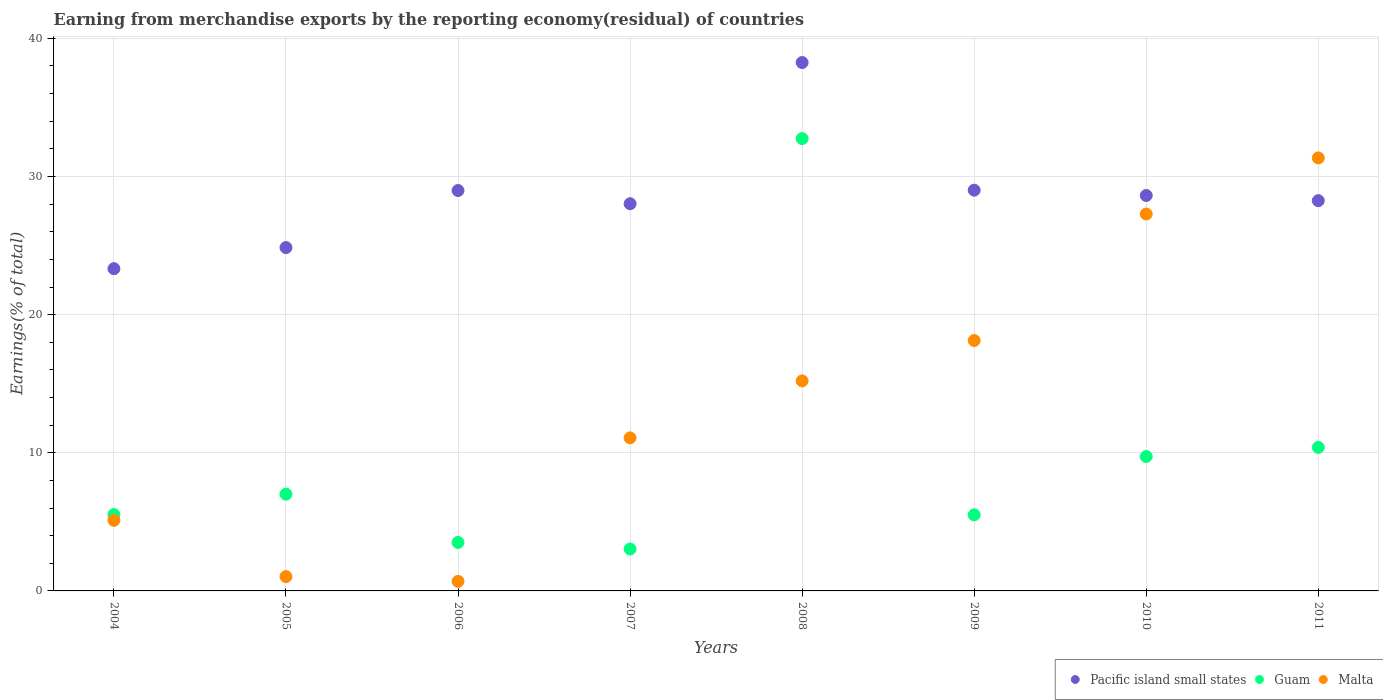How many different coloured dotlines are there?
Offer a terse response. 3. What is the percentage of amount earned from merchandise exports in Pacific island small states in 2006?
Keep it short and to the point. 28.99. Across all years, what is the maximum percentage of amount earned from merchandise exports in Guam?
Your response must be concise. 32.74. Across all years, what is the minimum percentage of amount earned from merchandise exports in Pacific island small states?
Ensure brevity in your answer.  23.33. What is the total percentage of amount earned from merchandise exports in Malta in the graph?
Keep it short and to the point. 109.88. What is the difference between the percentage of amount earned from merchandise exports in Guam in 2006 and that in 2011?
Ensure brevity in your answer.  -6.88. What is the difference between the percentage of amount earned from merchandise exports in Pacific island small states in 2006 and the percentage of amount earned from merchandise exports in Malta in 2004?
Your answer should be compact. 23.88. What is the average percentage of amount earned from merchandise exports in Malta per year?
Give a very brief answer. 13.74. In the year 2006, what is the difference between the percentage of amount earned from merchandise exports in Malta and percentage of amount earned from merchandise exports in Guam?
Keep it short and to the point. -2.82. What is the ratio of the percentage of amount earned from merchandise exports in Guam in 2005 to that in 2009?
Keep it short and to the point. 1.27. Is the difference between the percentage of amount earned from merchandise exports in Malta in 2010 and 2011 greater than the difference between the percentage of amount earned from merchandise exports in Guam in 2010 and 2011?
Keep it short and to the point. No. What is the difference between the highest and the second highest percentage of amount earned from merchandise exports in Guam?
Your answer should be very brief. 22.36. What is the difference between the highest and the lowest percentage of amount earned from merchandise exports in Guam?
Your answer should be very brief. 29.71. Is it the case that in every year, the sum of the percentage of amount earned from merchandise exports in Malta and percentage of amount earned from merchandise exports in Guam  is greater than the percentage of amount earned from merchandise exports in Pacific island small states?
Your answer should be very brief. No. Does the percentage of amount earned from merchandise exports in Guam monotonically increase over the years?
Keep it short and to the point. No. Is the percentage of amount earned from merchandise exports in Malta strictly less than the percentage of amount earned from merchandise exports in Pacific island small states over the years?
Offer a very short reply. No. How many dotlines are there?
Provide a short and direct response. 3. Does the graph contain grids?
Provide a succinct answer. Yes. Where does the legend appear in the graph?
Provide a succinct answer. Bottom right. How are the legend labels stacked?
Offer a terse response. Horizontal. What is the title of the graph?
Offer a very short reply. Earning from merchandise exports by the reporting economy(residual) of countries. Does "St. Lucia" appear as one of the legend labels in the graph?
Offer a terse response. No. What is the label or title of the X-axis?
Provide a succinct answer. Years. What is the label or title of the Y-axis?
Provide a succinct answer. Earnings(% of total). What is the Earnings(% of total) in Pacific island small states in 2004?
Offer a very short reply. 23.33. What is the Earnings(% of total) of Guam in 2004?
Your answer should be compact. 5.53. What is the Earnings(% of total) in Malta in 2004?
Ensure brevity in your answer.  5.11. What is the Earnings(% of total) of Pacific island small states in 2005?
Your answer should be very brief. 24.86. What is the Earnings(% of total) of Guam in 2005?
Keep it short and to the point. 7. What is the Earnings(% of total) of Malta in 2005?
Give a very brief answer. 1.04. What is the Earnings(% of total) in Pacific island small states in 2006?
Ensure brevity in your answer.  28.99. What is the Earnings(% of total) in Guam in 2006?
Your answer should be very brief. 3.51. What is the Earnings(% of total) of Malta in 2006?
Provide a short and direct response. 0.69. What is the Earnings(% of total) in Pacific island small states in 2007?
Offer a terse response. 28.03. What is the Earnings(% of total) in Guam in 2007?
Ensure brevity in your answer.  3.04. What is the Earnings(% of total) in Malta in 2007?
Provide a short and direct response. 11.08. What is the Earnings(% of total) in Pacific island small states in 2008?
Provide a succinct answer. 38.25. What is the Earnings(% of total) in Guam in 2008?
Provide a succinct answer. 32.74. What is the Earnings(% of total) of Malta in 2008?
Provide a short and direct response. 15.2. What is the Earnings(% of total) of Pacific island small states in 2009?
Offer a terse response. 29.01. What is the Earnings(% of total) in Guam in 2009?
Give a very brief answer. 5.51. What is the Earnings(% of total) in Malta in 2009?
Your response must be concise. 18.13. What is the Earnings(% of total) in Pacific island small states in 2010?
Offer a terse response. 28.63. What is the Earnings(% of total) of Guam in 2010?
Ensure brevity in your answer.  9.73. What is the Earnings(% of total) of Malta in 2010?
Ensure brevity in your answer.  27.29. What is the Earnings(% of total) in Pacific island small states in 2011?
Ensure brevity in your answer.  28.25. What is the Earnings(% of total) of Guam in 2011?
Give a very brief answer. 10.39. What is the Earnings(% of total) in Malta in 2011?
Provide a succinct answer. 31.34. Across all years, what is the maximum Earnings(% of total) of Pacific island small states?
Ensure brevity in your answer.  38.25. Across all years, what is the maximum Earnings(% of total) of Guam?
Offer a very short reply. 32.74. Across all years, what is the maximum Earnings(% of total) in Malta?
Keep it short and to the point. 31.34. Across all years, what is the minimum Earnings(% of total) of Pacific island small states?
Your answer should be very brief. 23.33. Across all years, what is the minimum Earnings(% of total) in Guam?
Offer a terse response. 3.04. Across all years, what is the minimum Earnings(% of total) in Malta?
Give a very brief answer. 0.69. What is the total Earnings(% of total) in Pacific island small states in the graph?
Ensure brevity in your answer.  229.34. What is the total Earnings(% of total) of Guam in the graph?
Give a very brief answer. 77.45. What is the total Earnings(% of total) of Malta in the graph?
Keep it short and to the point. 109.88. What is the difference between the Earnings(% of total) of Pacific island small states in 2004 and that in 2005?
Give a very brief answer. -1.53. What is the difference between the Earnings(% of total) of Guam in 2004 and that in 2005?
Keep it short and to the point. -1.48. What is the difference between the Earnings(% of total) of Malta in 2004 and that in 2005?
Keep it short and to the point. 4.07. What is the difference between the Earnings(% of total) of Pacific island small states in 2004 and that in 2006?
Offer a terse response. -5.66. What is the difference between the Earnings(% of total) in Guam in 2004 and that in 2006?
Provide a succinct answer. 2.02. What is the difference between the Earnings(% of total) of Malta in 2004 and that in 2006?
Offer a terse response. 4.42. What is the difference between the Earnings(% of total) in Pacific island small states in 2004 and that in 2007?
Your answer should be compact. -4.7. What is the difference between the Earnings(% of total) of Guam in 2004 and that in 2007?
Provide a succinct answer. 2.49. What is the difference between the Earnings(% of total) in Malta in 2004 and that in 2007?
Provide a succinct answer. -5.97. What is the difference between the Earnings(% of total) of Pacific island small states in 2004 and that in 2008?
Offer a terse response. -14.92. What is the difference between the Earnings(% of total) of Guam in 2004 and that in 2008?
Your answer should be compact. -27.22. What is the difference between the Earnings(% of total) of Malta in 2004 and that in 2008?
Make the answer very short. -10.09. What is the difference between the Earnings(% of total) in Pacific island small states in 2004 and that in 2009?
Make the answer very short. -5.68. What is the difference between the Earnings(% of total) of Guam in 2004 and that in 2009?
Ensure brevity in your answer.  0.02. What is the difference between the Earnings(% of total) in Malta in 2004 and that in 2009?
Provide a succinct answer. -13.02. What is the difference between the Earnings(% of total) of Pacific island small states in 2004 and that in 2010?
Provide a succinct answer. -5.3. What is the difference between the Earnings(% of total) of Guam in 2004 and that in 2010?
Your answer should be very brief. -4.2. What is the difference between the Earnings(% of total) in Malta in 2004 and that in 2010?
Your response must be concise. -22.18. What is the difference between the Earnings(% of total) in Pacific island small states in 2004 and that in 2011?
Ensure brevity in your answer.  -4.92. What is the difference between the Earnings(% of total) of Guam in 2004 and that in 2011?
Your response must be concise. -4.86. What is the difference between the Earnings(% of total) in Malta in 2004 and that in 2011?
Offer a terse response. -26.23. What is the difference between the Earnings(% of total) of Pacific island small states in 2005 and that in 2006?
Your response must be concise. -4.13. What is the difference between the Earnings(% of total) in Guam in 2005 and that in 2006?
Your answer should be compact. 3.49. What is the difference between the Earnings(% of total) in Malta in 2005 and that in 2006?
Your response must be concise. 0.35. What is the difference between the Earnings(% of total) in Pacific island small states in 2005 and that in 2007?
Your answer should be compact. -3.17. What is the difference between the Earnings(% of total) in Guam in 2005 and that in 2007?
Your answer should be compact. 3.97. What is the difference between the Earnings(% of total) of Malta in 2005 and that in 2007?
Your answer should be compact. -10.04. What is the difference between the Earnings(% of total) in Pacific island small states in 2005 and that in 2008?
Offer a very short reply. -13.4. What is the difference between the Earnings(% of total) in Guam in 2005 and that in 2008?
Make the answer very short. -25.74. What is the difference between the Earnings(% of total) in Malta in 2005 and that in 2008?
Your response must be concise. -14.17. What is the difference between the Earnings(% of total) of Pacific island small states in 2005 and that in 2009?
Your answer should be very brief. -4.15. What is the difference between the Earnings(% of total) in Guam in 2005 and that in 2009?
Provide a succinct answer. 1.5. What is the difference between the Earnings(% of total) of Malta in 2005 and that in 2009?
Keep it short and to the point. -17.09. What is the difference between the Earnings(% of total) of Pacific island small states in 2005 and that in 2010?
Offer a very short reply. -3.77. What is the difference between the Earnings(% of total) in Guam in 2005 and that in 2010?
Ensure brevity in your answer.  -2.73. What is the difference between the Earnings(% of total) of Malta in 2005 and that in 2010?
Provide a succinct answer. -26.25. What is the difference between the Earnings(% of total) in Pacific island small states in 2005 and that in 2011?
Provide a short and direct response. -3.4. What is the difference between the Earnings(% of total) of Guam in 2005 and that in 2011?
Ensure brevity in your answer.  -3.39. What is the difference between the Earnings(% of total) of Malta in 2005 and that in 2011?
Offer a terse response. -30.31. What is the difference between the Earnings(% of total) in Pacific island small states in 2006 and that in 2007?
Provide a short and direct response. 0.96. What is the difference between the Earnings(% of total) of Guam in 2006 and that in 2007?
Provide a succinct answer. 0.47. What is the difference between the Earnings(% of total) of Malta in 2006 and that in 2007?
Provide a succinct answer. -10.39. What is the difference between the Earnings(% of total) in Pacific island small states in 2006 and that in 2008?
Your response must be concise. -9.27. What is the difference between the Earnings(% of total) of Guam in 2006 and that in 2008?
Make the answer very short. -29.23. What is the difference between the Earnings(% of total) of Malta in 2006 and that in 2008?
Ensure brevity in your answer.  -14.51. What is the difference between the Earnings(% of total) in Pacific island small states in 2006 and that in 2009?
Your answer should be very brief. -0.02. What is the difference between the Earnings(% of total) of Guam in 2006 and that in 2009?
Offer a terse response. -2. What is the difference between the Earnings(% of total) of Malta in 2006 and that in 2009?
Keep it short and to the point. -17.44. What is the difference between the Earnings(% of total) in Pacific island small states in 2006 and that in 2010?
Provide a succinct answer. 0.36. What is the difference between the Earnings(% of total) of Guam in 2006 and that in 2010?
Make the answer very short. -6.22. What is the difference between the Earnings(% of total) in Malta in 2006 and that in 2010?
Your response must be concise. -26.59. What is the difference between the Earnings(% of total) in Pacific island small states in 2006 and that in 2011?
Ensure brevity in your answer.  0.73. What is the difference between the Earnings(% of total) in Guam in 2006 and that in 2011?
Provide a short and direct response. -6.88. What is the difference between the Earnings(% of total) in Malta in 2006 and that in 2011?
Give a very brief answer. -30.65. What is the difference between the Earnings(% of total) of Pacific island small states in 2007 and that in 2008?
Provide a short and direct response. -10.22. What is the difference between the Earnings(% of total) in Guam in 2007 and that in 2008?
Keep it short and to the point. -29.71. What is the difference between the Earnings(% of total) of Malta in 2007 and that in 2008?
Make the answer very short. -4.12. What is the difference between the Earnings(% of total) in Pacific island small states in 2007 and that in 2009?
Your response must be concise. -0.98. What is the difference between the Earnings(% of total) in Guam in 2007 and that in 2009?
Give a very brief answer. -2.47. What is the difference between the Earnings(% of total) in Malta in 2007 and that in 2009?
Ensure brevity in your answer.  -7.05. What is the difference between the Earnings(% of total) in Pacific island small states in 2007 and that in 2010?
Your response must be concise. -0.6. What is the difference between the Earnings(% of total) in Guam in 2007 and that in 2010?
Offer a very short reply. -6.69. What is the difference between the Earnings(% of total) of Malta in 2007 and that in 2010?
Your answer should be very brief. -16.2. What is the difference between the Earnings(% of total) in Pacific island small states in 2007 and that in 2011?
Make the answer very short. -0.22. What is the difference between the Earnings(% of total) of Guam in 2007 and that in 2011?
Provide a short and direct response. -7.35. What is the difference between the Earnings(% of total) of Malta in 2007 and that in 2011?
Your answer should be compact. -20.26. What is the difference between the Earnings(% of total) of Pacific island small states in 2008 and that in 2009?
Keep it short and to the point. 9.24. What is the difference between the Earnings(% of total) in Guam in 2008 and that in 2009?
Make the answer very short. 27.24. What is the difference between the Earnings(% of total) of Malta in 2008 and that in 2009?
Ensure brevity in your answer.  -2.92. What is the difference between the Earnings(% of total) in Pacific island small states in 2008 and that in 2010?
Keep it short and to the point. 9.63. What is the difference between the Earnings(% of total) of Guam in 2008 and that in 2010?
Ensure brevity in your answer.  23.02. What is the difference between the Earnings(% of total) of Malta in 2008 and that in 2010?
Offer a very short reply. -12.08. What is the difference between the Earnings(% of total) of Pacific island small states in 2008 and that in 2011?
Give a very brief answer. 10. What is the difference between the Earnings(% of total) in Guam in 2008 and that in 2011?
Give a very brief answer. 22.36. What is the difference between the Earnings(% of total) in Malta in 2008 and that in 2011?
Make the answer very short. -16.14. What is the difference between the Earnings(% of total) in Pacific island small states in 2009 and that in 2010?
Keep it short and to the point. 0.38. What is the difference between the Earnings(% of total) of Guam in 2009 and that in 2010?
Make the answer very short. -4.22. What is the difference between the Earnings(% of total) of Malta in 2009 and that in 2010?
Your answer should be very brief. -9.16. What is the difference between the Earnings(% of total) in Pacific island small states in 2009 and that in 2011?
Ensure brevity in your answer.  0.76. What is the difference between the Earnings(% of total) in Guam in 2009 and that in 2011?
Give a very brief answer. -4.88. What is the difference between the Earnings(% of total) in Malta in 2009 and that in 2011?
Ensure brevity in your answer.  -13.22. What is the difference between the Earnings(% of total) of Pacific island small states in 2010 and that in 2011?
Your response must be concise. 0.37. What is the difference between the Earnings(% of total) of Guam in 2010 and that in 2011?
Make the answer very short. -0.66. What is the difference between the Earnings(% of total) of Malta in 2010 and that in 2011?
Provide a short and direct response. -4.06. What is the difference between the Earnings(% of total) of Pacific island small states in 2004 and the Earnings(% of total) of Guam in 2005?
Make the answer very short. 16.32. What is the difference between the Earnings(% of total) in Pacific island small states in 2004 and the Earnings(% of total) in Malta in 2005?
Your answer should be very brief. 22.29. What is the difference between the Earnings(% of total) of Guam in 2004 and the Earnings(% of total) of Malta in 2005?
Keep it short and to the point. 4.49. What is the difference between the Earnings(% of total) of Pacific island small states in 2004 and the Earnings(% of total) of Guam in 2006?
Your response must be concise. 19.82. What is the difference between the Earnings(% of total) in Pacific island small states in 2004 and the Earnings(% of total) in Malta in 2006?
Your answer should be very brief. 22.64. What is the difference between the Earnings(% of total) of Guam in 2004 and the Earnings(% of total) of Malta in 2006?
Offer a terse response. 4.84. What is the difference between the Earnings(% of total) in Pacific island small states in 2004 and the Earnings(% of total) in Guam in 2007?
Offer a terse response. 20.29. What is the difference between the Earnings(% of total) in Pacific island small states in 2004 and the Earnings(% of total) in Malta in 2007?
Your answer should be very brief. 12.25. What is the difference between the Earnings(% of total) in Guam in 2004 and the Earnings(% of total) in Malta in 2007?
Your response must be concise. -5.55. What is the difference between the Earnings(% of total) of Pacific island small states in 2004 and the Earnings(% of total) of Guam in 2008?
Your response must be concise. -9.42. What is the difference between the Earnings(% of total) in Pacific island small states in 2004 and the Earnings(% of total) in Malta in 2008?
Your answer should be very brief. 8.12. What is the difference between the Earnings(% of total) of Guam in 2004 and the Earnings(% of total) of Malta in 2008?
Your answer should be very brief. -9.68. What is the difference between the Earnings(% of total) of Pacific island small states in 2004 and the Earnings(% of total) of Guam in 2009?
Give a very brief answer. 17.82. What is the difference between the Earnings(% of total) in Pacific island small states in 2004 and the Earnings(% of total) in Malta in 2009?
Your response must be concise. 5.2. What is the difference between the Earnings(% of total) in Guam in 2004 and the Earnings(% of total) in Malta in 2009?
Provide a succinct answer. -12.6. What is the difference between the Earnings(% of total) in Pacific island small states in 2004 and the Earnings(% of total) in Guam in 2010?
Offer a very short reply. 13.6. What is the difference between the Earnings(% of total) in Pacific island small states in 2004 and the Earnings(% of total) in Malta in 2010?
Provide a succinct answer. -3.96. What is the difference between the Earnings(% of total) in Guam in 2004 and the Earnings(% of total) in Malta in 2010?
Make the answer very short. -21.76. What is the difference between the Earnings(% of total) in Pacific island small states in 2004 and the Earnings(% of total) in Guam in 2011?
Offer a very short reply. 12.94. What is the difference between the Earnings(% of total) in Pacific island small states in 2004 and the Earnings(% of total) in Malta in 2011?
Provide a short and direct response. -8.02. What is the difference between the Earnings(% of total) in Guam in 2004 and the Earnings(% of total) in Malta in 2011?
Your response must be concise. -25.82. What is the difference between the Earnings(% of total) of Pacific island small states in 2005 and the Earnings(% of total) of Guam in 2006?
Ensure brevity in your answer.  21.35. What is the difference between the Earnings(% of total) in Pacific island small states in 2005 and the Earnings(% of total) in Malta in 2006?
Your answer should be compact. 24.16. What is the difference between the Earnings(% of total) in Guam in 2005 and the Earnings(% of total) in Malta in 2006?
Your answer should be very brief. 6.31. What is the difference between the Earnings(% of total) in Pacific island small states in 2005 and the Earnings(% of total) in Guam in 2007?
Give a very brief answer. 21.82. What is the difference between the Earnings(% of total) of Pacific island small states in 2005 and the Earnings(% of total) of Malta in 2007?
Offer a very short reply. 13.78. What is the difference between the Earnings(% of total) of Guam in 2005 and the Earnings(% of total) of Malta in 2007?
Your answer should be very brief. -4.08. What is the difference between the Earnings(% of total) of Pacific island small states in 2005 and the Earnings(% of total) of Guam in 2008?
Give a very brief answer. -7.89. What is the difference between the Earnings(% of total) of Pacific island small states in 2005 and the Earnings(% of total) of Malta in 2008?
Make the answer very short. 9.65. What is the difference between the Earnings(% of total) of Guam in 2005 and the Earnings(% of total) of Malta in 2008?
Give a very brief answer. -8.2. What is the difference between the Earnings(% of total) in Pacific island small states in 2005 and the Earnings(% of total) in Guam in 2009?
Ensure brevity in your answer.  19.35. What is the difference between the Earnings(% of total) in Pacific island small states in 2005 and the Earnings(% of total) in Malta in 2009?
Give a very brief answer. 6.73. What is the difference between the Earnings(% of total) in Guam in 2005 and the Earnings(% of total) in Malta in 2009?
Your answer should be compact. -11.12. What is the difference between the Earnings(% of total) in Pacific island small states in 2005 and the Earnings(% of total) in Guam in 2010?
Keep it short and to the point. 15.13. What is the difference between the Earnings(% of total) of Pacific island small states in 2005 and the Earnings(% of total) of Malta in 2010?
Offer a terse response. -2.43. What is the difference between the Earnings(% of total) of Guam in 2005 and the Earnings(% of total) of Malta in 2010?
Make the answer very short. -20.28. What is the difference between the Earnings(% of total) in Pacific island small states in 2005 and the Earnings(% of total) in Guam in 2011?
Ensure brevity in your answer.  14.47. What is the difference between the Earnings(% of total) of Pacific island small states in 2005 and the Earnings(% of total) of Malta in 2011?
Keep it short and to the point. -6.49. What is the difference between the Earnings(% of total) in Guam in 2005 and the Earnings(% of total) in Malta in 2011?
Offer a terse response. -24.34. What is the difference between the Earnings(% of total) in Pacific island small states in 2006 and the Earnings(% of total) in Guam in 2007?
Your response must be concise. 25.95. What is the difference between the Earnings(% of total) of Pacific island small states in 2006 and the Earnings(% of total) of Malta in 2007?
Give a very brief answer. 17.9. What is the difference between the Earnings(% of total) in Guam in 2006 and the Earnings(% of total) in Malta in 2007?
Provide a short and direct response. -7.57. What is the difference between the Earnings(% of total) of Pacific island small states in 2006 and the Earnings(% of total) of Guam in 2008?
Offer a terse response. -3.76. What is the difference between the Earnings(% of total) of Pacific island small states in 2006 and the Earnings(% of total) of Malta in 2008?
Make the answer very short. 13.78. What is the difference between the Earnings(% of total) in Guam in 2006 and the Earnings(% of total) in Malta in 2008?
Your answer should be very brief. -11.69. What is the difference between the Earnings(% of total) in Pacific island small states in 2006 and the Earnings(% of total) in Guam in 2009?
Ensure brevity in your answer.  23.48. What is the difference between the Earnings(% of total) of Pacific island small states in 2006 and the Earnings(% of total) of Malta in 2009?
Provide a succinct answer. 10.86. What is the difference between the Earnings(% of total) of Guam in 2006 and the Earnings(% of total) of Malta in 2009?
Your answer should be very brief. -14.62. What is the difference between the Earnings(% of total) of Pacific island small states in 2006 and the Earnings(% of total) of Guam in 2010?
Offer a very short reply. 19.26. What is the difference between the Earnings(% of total) of Pacific island small states in 2006 and the Earnings(% of total) of Malta in 2010?
Your answer should be compact. 1.7. What is the difference between the Earnings(% of total) in Guam in 2006 and the Earnings(% of total) in Malta in 2010?
Keep it short and to the point. -23.77. What is the difference between the Earnings(% of total) in Pacific island small states in 2006 and the Earnings(% of total) in Guam in 2011?
Your answer should be compact. 18.6. What is the difference between the Earnings(% of total) of Pacific island small states in 2006 and the Earnings(% of total) of Malta in 2011?
Give a very brief answer. -2.36. What is the difference between the Earnings(% of total) of Guam in 2006 and the Earnings(% of total) of Malta in 2011?
Give a very brief answer. -27.83. What is the difference between the Earnings(% of total) of Pacific island small states in 2007 and the Earnings(% of total) of Guam in 2008?
Your response must be concise. -4.72. What is the difference between the Earnings(% of total) in Pacific island small states in 2007 and the Earnings(% of total) in Malta in 2008?
Make the answer very short. 12.83. What is the difference between the Earnings(% of total) in Guam in 2007 and the Earnings(% of total) in Malta in 2008?
Your answer should be compact. -12.17. What is the difference between the Earnings(% of total) in Pacific island small states in 2007 and the Earnings(% of total) in Guam in 2009?
Give a very brief answer. 22.52. What is the difference between the Earnings(% of total) in Pacific island small states in 2007 and the Earnings(% of total) in Malta in 2009?
Offer a very short reply. 9.9. What is the difference between the Earnings(% of total) of Guam in 2007 and the Earnings(% of total) of Malta in 2009?
Keep it short and to the point. -15.09. What is the difference between the Earnings(% of total) of Pacific island small states in 2007 and the Earnings(% of total) of Guam in 2010?
Provide a succinct answer. 18.3. What is the difference between the Earnings(% of total) of Pacific island small states in 2007 and the Earnings(% of total) of Malta in 2010?
Offer a terse response. 0.74. What is the difference between the Earnings(% of total) of Guam in 2007 and the Earnings(% of total) of Malta in 2010?
Offer a terse response. -24.25. What is the difference between the Earnings(% of total) in Pacific island small states in 2007 and the Earnings(% of total) in Guam in 2011?
Provide a short and direct response. 17.64. What is the difference between the Earnings(% of total) in Pacific island small states in 2007 and the Earnings(% of total) in Malta in 2011?
Offer a very short reply. -3.31. What is the difference between the Earnings(% of total) of Guam in 2007 and the Earnings(% of total) of Malta in 2011?
Make the answer very short. -28.31. What is the difference between the Earnings(% of total) of Pacific island small states in 2008 and the Earnings(% of total) of Guam in 2009?
Ensure brevity in your answer.  32.74. What is the difference between the Earnings(% of total) in Pacific island small states in 2008 and the Earnings(% of total) in Malta in 2009?
Your answer should be very brief. 20.12. What is the difference between the Earnings(% of total) of Guam in 2008 and the Earnings(% of total) of Malta in 2009?
Your response must be concise. 14.62. What is the difference between the Earnings(% of total) of Pacific island small states in 2008 and the Earnings(% of total) of Guam in 2010?
Ensure brevity in your answer.  28.52. What is the difference between the Earnings(% of total) of Pacific island small states in 2008 and the Earnings(% of total) of Malta in 2010?
Provide a succinct answer. 10.97. What is the difference between the Earnings(% of total) in Guam in 2008 and the Earnings(% of total) in Malta in 2010?
Provide a short and direct response. 5.46. What is the difference between the Earnings(% of total) in Pacific island small states in 2008 and the Earnings(% of total) in Guam in 2011?
Your answer should be very brief. 27.86. What is the difference between the Earnings(% of total) in Pacific island small states in 2008 and the Earnings(% of total) in Malta in 2011?
Your response must be concise. 6.91. What is the difference between the Earnings(% of total) in Guam in 2008 and the Earnings(% of total) in Malta in 2011?
Make the answer very short. 1.4. What is the difference between the Earnings(% of total) of Pacific island small states in 2009 and the Earnings(% of total) of Guam in 2010?
Ensure brevity in your answer.  19.28. What is the difference between the Earnings(% of total) of Pacific island small states in 2009 and the Earnings(% of total) of Malta in 2010?
Ensure brevity in your answer.  1.72. What is the difference between the Earnings(% of total) in Guam in 2009 and the Earnings(% of total) in Malta in 2010?
Provide a succinct answer. -21.78. What is the difference between the Earnings(% of total) of Pacific island small states in 2009 and the Earnings(% of total) of Guam in 2011?
Your answer should be compact. 18.62. What is the difference between the Earnings(% of total) of Pacific island small states in 2009 and the Earnings(% of total) of Malta in 2011?
Your response must be concise. -2.33. What is the difference between the Earnings(% of total) of Guam in 2009 and the Earnings(% of total) of Malta in 2011?
Your response must be concise. -25.84. What is the difference between the Earnings(% of total) of Pacific island small states in 2010 and the Earnings(% of total) of Guam in 2011?
Offer a terse response. 18.24. What is the difference between the Earnings(% of total) of Pacific island small states in 2010 and the Earnings(% of total) of Malta in 2011?
Ensure brevity in your answer.  -2.72. What is the difference between the Earnings(% of total) of Guam in 2010 and the Earnings(% of total) of Malta in 2011?
Your answer should be very brief. -21.62. What is the average Earnings(% of total) in Pacific island small states per year?
Make the answer very short. 28.67. What is the average Earnings(% of total) of Guam per year?
Your answer should be very brief. 9.68. What is the average Earnings(% of total) in Malta per year?
Your answer should be very brief. 13.74. In the year 2004, what is the difference between the Earnings(% of total) of Pacific island small states and Earnings(% of total) of Guam?
Make the answer very short. 17.8. In the year 2004, what is the difference between the Earnings(% of total) of Pacific island small states and Earnings(% of total) of Malta?
Your answer should be very brief. 18.22. In the year 2004, what is the difference between the Earnings(% of total) in Guam and Earnings(% of total) in Malta?
Ensure brevity in your answer.  0.42. In the year 2005, what is the difference between the Earnings(% of total) in Pacific island small states and Earnings(% of total) in Guam?
Keep it short and to the point. 17.85. In the year 2005, what is the difference between the Earnings(% of total) in Pacific island small states and Earnings(% of total) in Malta?
Your response must be concise. 23.82. In the year 2005, what is the difference between the Earnings(% of total) of Guam and Earnings(% of total) of Malta?
Ensure brevity in your answer.  5.97. In the year 2006, what is the difference between the Earnings(% of total) of Pacific island small states and Earnings(% of total) of Guam?
Your answer should be very brief. 25.47. In the year 2006, what is the difference between the Earnings(% of total) in Pacific island small states and Earnings(% of total) in Malta?
Make the answer very short. 28.29. In the year 2006, what is the difference between the Earnings(% of total) of Guam and Earnings(% of total) of Malta?
Give a very brief answer. 2.82. In the year 2007, what is the difference between the Earnings(% of total) in Pacific island small states and Earnings(% of total) in Guam?
Offer a terse response. 24.99. In the year 2007, what is the difference between the Earnings(% of total) in Pacific island small states and Earnings(% of total) in Malta?
Your response must be concise. 16.95. In the year 2007, what is the difference between the Earnings(% of total) in Guam and Earnings(% of total) in Malta?
Make the answer very short. -8.04. In the year 2008, what is the difference between the Earnings(% of total) of Pacific island small states and Earnings(% of total) of Guam?
Your answer should be very brief. 5.51. In the year 2008, what is the difference between the Earnings(% of total) in Pacific island small states and Earnings(% of total) in Malta?
Your answer should be very brief. 23.05. In the year 2008, what is the difference between the Earnings(% of total) in Guam and Earnings(% of total) in Malta?
Provide a short and direct response. 17.54. In the year 2009, what is the difference between the Earnings(% of total) of Pacific island small states and Earnings(% of total) of Guam?
Make the answer very short. 23.5. In the year 2009, what is the difference between the Earnings(% of total) of Pacific island small states and Earnings(% of total) of Malta?
Your response must be concise. 10.88. In the year 2009, what is the difference between the Earnings(% of total) of Guam and Earnings(% of total) of Malta?
Give a very brief answer. -12.62. In the year 2010, what is the difference between the Earnings(% of total) in Pacific island small states and Earnings(% of total) in Guam?
Make the answer very short. 18.9. In the year 2010, what is the difference between the Earnings(% of total) in Pacific island small states and Earnings(% of total) in Malta?
Give a very brief answer. 1.34. In the year 2010, what is the difference between the Earnings(% of total) in Guam and Earnings(% of total) in Malta?
Your response must be concise. -17.56. In the year 2011, what is the difference between the Earnings(% of total) of Pacific island small states and Earnings(% of total) of Guam?
Make the answer very short. 17.86. In the year 2011, what is the difference between the Earnings(% of total) of Pacific island small states and Earnings(% of total) of Malta?
Offer a very short reply. -3.09. In the year 2011, what is the difference between the Earnings(% of total) in Guam and Earnings(% of total) in Malta?
Keep it short and to the point. -20.95. What is the ratio of the Earnings(% of total) in Pacific island small states in 2004 to that in 2005?
Give a very brief answer. 0.94. What is the ratio of the Earnings(% of total) in Guam in 2004 to that in 2005?
Keep it short and to the point. 0.79. What is the ratio of the Earnings(% of total) of Malta in 2004 to that in 2005?
Ensure brevity in your answer.  4.93. What is the ratio of the Earnings(% of total) of Pacific island small states in 2004 to that in 2006?
Ensure brevity in your answer.  0.8. What is the ratio of the Earnings(% of total) of Guam in 2004 to that in 2006?
Keep it short and to the point. 1.57. What is the ratio of the Earnings(% of total) in Malta in 2004 to that in 2006?
Your response must be concise. 7.38. What is the ratio of the Earnings(% of total) in Pacific island small states in 2004 to that in 2007?
Provide a short and direct response. 0.83. What is the ratio of the Earnings(% of total) in Guam in 2004 to that in 2007?
Keep it short and to the point. 1.82. What is the ratio of the Earnings(% of total) of Malta in 2004 to that in 2007?
Offer a very short reply. 0.46. What is the ratio of the Earnings(% of total) of Pacific island small states in 2004 to that in 2008?
Provide a short and direct response. 0.61. What is the ratio of the Earnings(% of total) of Guam in 2004 to that in 2008?
Offer a very short reply. 0.17. What is the ratio of the Earnings(% of total) of Malta in 2004 to that in 2008?
Keep it short and to the point. 0.34. What is the ratio of the Earnings(% of total) in Pacific island small states in 2004 to that in 2009?
Provide a short and direct response. 0.8. What is the ratio of the Earnings(% of total) in Malta in 2004 to that in 2009?
Give a very brief answer. 0.28. What is the ratio of the Earnings(% of total) in Pacific island small states in 2004 to that in 2010?
Your answer should be very brief. 0.81. What is the ratio of the Earnings(% of total) of Guam in 2004 to that in 2010?
Provide a short and direct response. 0.57. What is the ratio of the Earnings(% of total) of Malta in 2004 to that in 2010?
Your answer should be compact. 0.19. What is the ratio of the Earnings(% of total) of Pacific island small states in 2004 to that in 2011?
Offer a very short reply. 0.83. What is the ratio of the Earnings(% of total) in Guam in 2004 to that in 2011?
Offer a terse response. 0.53. What is the ratio of the Earnings(% of total) of Malta in 2004 to that in 2011?
Keep it short and to the point. 0.16. What is the ratio of the Earnings(% of total) of Pacific island small states in 2005 to that in 2006?
Offer a very short reply. 0.86. What is the ratio of the Earnings(% of total) in Guam in 2005 to that in 2006?
Ensure brevity in your answer.  1.99. What is the ratio of the Earnings(% of total) in Malta in 2005 to that in 2006?
Make the answer very short. 1.5. What is the ratio of the Earnings(% of total) of Pacific island small states in 2005 to that in 2007?
Keep it short and to the point. 0.89. What is the ratio of the Earnings(% of total) in Guam in 2005 to that in 2007?
Provide a succinct answer. 2.31. What is the ratio of the Earnings(% of total) in Malta in 2005 to that in 2007?
Your answer should be very brief. 0.09. What is the ratio of the Earnings(% of total) in Pacific island small states in 2005 to that in 2008?
Keep it short and to the point. 0.65. What is the ratio of the Earnings(% of total) in Guam in 2005 to that in 2008?
Offer a very short reply. 0.21. What is the ratio of the Earnings(% of total) of Malta in 2005 to that in 2008?
Offer a terse response. 0.07. What is the ratio of the Earnings(% of total) of Pacific island small states in 2005 to that in 2009?
Your answer should be very brief. 0.86. What is the ratio of the Earnings(% of total) of Guam in 2005 to that in 2009?
Offer a very short reply. 1.27. What is the ratio of the Earnings(% of total) of Malta in 2005 to that in 2009?
Keep it short and to the point. 0.06. What is the ratio of the Earnings(% of total) of Pacific island small states in 2005 to that in 2010?
Your answer should be very brief. 0.87. What is the ratio of the Earnings(% of total) in Guam in 2005 to that in 2010?
Your answer should be very brief. 0.72. What is the ratio of the Earnings(% of total) of Malta in 2005 to that in 2010?
Make the answer very short. 0.04. What is the ratio of the Earnings(% of total) of Pacific island small states in 2005 to that in 2011?
Your answer should be very brief. 0.88. What is the ratio of the Earnings(% of total) of Guam in 2005 to that in 2011?
Offer a terse response. 0.67. What is the ratio of the Earnings(% of total) of Malta in 2005 to that in 2011?
Provide a short and direct response. 0.03. What is the ratio of the Earnings(% of total) of Pacific island small states in 2006 to that in 2007?
Provide a short and direct response. 1.03. What is the ratio of the Earnings(% of total) in Guam in 2006 to that in 2007?
Provide a short and direct response. 1.16. What is the ratio of the Earnings(% of total) of Malta in 2006 to that in 2007?
Ensure brevity in your answer.  0.06. What is the ratio of the Earnings(% of total) in Pacific island small states in 2006 to that in 2008?
Your answer should be very brief. 0.76. What is the ratio of the Earnings(% of total) of Guam in 2006 to that in 2008?
Provide a short and direct response. 0.11. What is the ratio of the Earnings(% of total) of Malta in 2006 to that in 2008?
Your response must be concise. 0.05. What is the ratio of the Earnings(% of total) in Pacific island small states in 2006 to that in 2009?
Offer a very short reply. 1. What is the ratio of the Earnings(% of total) of Guam in 2006 to that in 2009?
Offer a very short reply. 0.64. What is the ratio of the Earnings(% of total) in Malta in 2006 to that in 2009?
Your answer should be compact. 0.04. What is the ratio of the Earnings(% of total) of Pacific island small states in 2006 to that in 2010?
Make the answer very short. 1.01. What is the ratio of the Earnings(% of total) in Guam in 2006 to that in 2010?
Keep it short and to the point. 0.36. What is the ratio of the Earnings(% of total) in Malta in 2006 to that in 2010?
Offer a terse response. 0.03. What is the ratio of the Earnings(% of total) of Guam in 2006 to that in 2011?
Give a very brief answer. 0.34. What is the ratio of the Earnings(% of total) in Malta in 2006 to that in 2011?
Provide a short and direct response. 0.02. What is the ratio of the Earnings(% of total) of Pacific island small states in 2007 to that in 2008?
Give a very brief answer. 0.73. What is the ratio of the Earnings(% of total) in Guam in 2007 to that in 2008?
Provide a short and direct response. 0.09. What is the ratio of the Earnings(% of total) in Malta in 2007 to that in 2008?
Your response must be concise. 0.73. What is the ratio of the Earnings(% of total) in Pacific island small states in 2007 to that in 2009?
Give a very brief answer. 0.97. What is the ratio of the Earnings(% of total) in Guam in 2007 to that in 2009?
Keep it short and to the point. 0.55. What is the ratio of the Earnings(% of total) of Malta in 2007 to that in 2009?
Make the answer very short. 0.61. What is the ratio of the Earnings(% of total) in Pacific island small states in 2007 to that in 2010?
Your response must be concise. 0.98. What is the ratio of the Earnings(% of total) of Guam in 2007 to that in 2010?
Keep it short and to the point. 0.31. What is the ratio of the Earnings(% of total) in Malta in 2007 to that in 2010?
Your response must be concise. 0.41. What is the ratio of the Earnings(% of total) of Pacific island small states in 2007 to that in 2011?
Your response must be concise. 0.99. What is the ratio of the Earnings(% of total) in Guam in 2007 to that in 2011?
Offer a very short reply. 0.29. What is the ratio of the Earnings(% of total) of Malta in 2007 to that in 2011?
Your answer should be very brief. 0.35. What is the ratio of the Earnings(% of total) of Pacific island small states in 2008 to that in 2009?
Provide a succinct answer. 1.32. What is the ratio of the Earnings(% of total) in Guam in 2008 to that in 2009?
Your answer should be compact. 5.95. What is the ratio of the Earnings(% of total) in Malta in 2008 to that in 2009?
Your response must be concise. 0.84. What is the ratio of the Earnings(% of total) in Pacific island small states in 2008 to that in 2010?
Your response must be concise. 1.34. What is the ratio of the Earnings(% of total) in Guam in 2008 to that in 2010?
Keep it short and to the point. 3.37. What is the ratio of the Earnings(% of total) in Malta in 2008 to that in 2010?
Your answer should be compact. 0.56. What is the ratio of the Earnings(% of total) in Pacific island small states in 2008 to that in 2011?
Your answer should be compact. 1.35. What is the ratio of the Earnings(% of total) in Guam in 2008 to that in 2011?
Offer a very short reply. 3.15. What is the ratio of the Earnings(% of total) of Malta in 2008 to that in 2011?
Make the answer very short. 0.49. What is the ratio of the Earnings(% of total) of Pacific island small states in 2009 to that in 2010?
Keep it short and to the point. 1.01. What is the ratio of the Earnings(% of total) of Guam in 2009 to that in 2010?
Your answer should be very brief. 0.57. What is the ratio of the Earnings(% of total) of Malta in 2009 to that in 2010?
Provide a short and direct response. 0.66. What is the ratio of the Earnings(% of total) of Pacific island small states in 2009 to that in 2011?
Ensure brevity in your answer.  1.03. What is the ratio of the Earnings(% of total) of Guam in 2009 to that in 2011?
Offer a terse response. 0.53. What is the ratio of the Earnings(% of total) in Malta in 2009 to that in 2011?
Give a very brief answer. 0.58. What is the ratio of the Earnings(% of total) in Pacific island small states in 2010 to that in 2011?
Keep it short and to the point. 1.01. What is the ratio of the Earnings(% of total) of Guam in 2010 to that in 2011?
Provide a short and direct response. 0.94. What is the ratio of the Earnings(% of total) of Malta in 2010 to that in 2011?
Keep it short and to the point. 0.87. What is the difference between the highest and the second highest Earnings(% of total) of Pacific island small states?
Provide a short and direct response. 9.24. What is the difference between the highest and the second highest Earnings(% of total) in Guam?
Offer a very short reply. 22.36. What is the difference between the highest and the second highest Earnings(% of total) of Malta?
Your response must be concise. 4.06. What is the difference between the highest and the lowest Earnings(% of total) in Pacific island small states?
Give a very brief answer. 14.92. What is the difference between the highest and the lowest Earnings(% of total) of Guam?
Give a very brief answer. 29.71. What is the difference between the highest and the lowest Earnings(% of total) of Malta?
Ensure brevity in your answer.  30.65. 